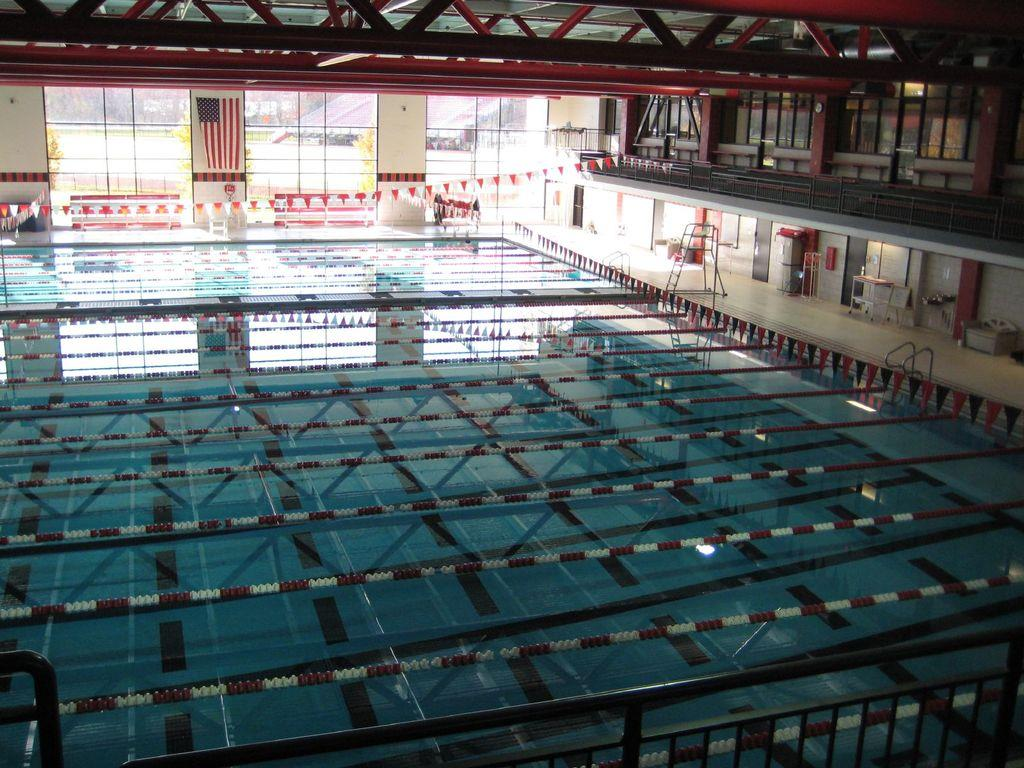What is the main feature in the image? There is a swimming pool in the image. What can be seen on the right side of the image? There is a stand on the right side of the image. What type of architectural feature is visible in the background of the image? There are glass windows in the background of the image. Can you tell me how many porters are carrying the cable in the image? There is no cable or porter present in the image. What type of foot is visible on the stand in the image? There is no foot visible on the stand in the image. 